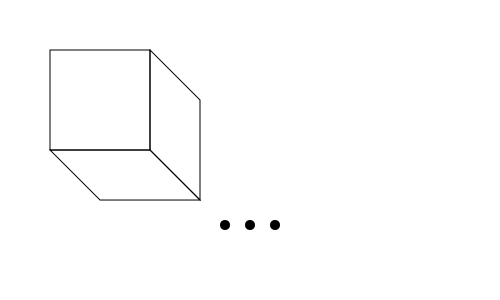In this fractal geometry pattern, what shape will appear in the next iteration, and where will it be positioned relative to the current structure? To determine the next iteration in this fractal pattern, we need to analyze the current structure and identify the rule for progression:

1. The base shape is a square.
2. In each iteration, three new squares are added:
   a. One to the right, tilted 45 degrees clockwise
   b. One below, tilted 45 degrees counterclockwise
   c. One to the bottom-right, maintaining the original orientation

3. The new squares are smaller, with side lengths approximately $\frac{1}{\sqrt{2}}$ times the previous square's side length.

4. This process creates a self-similar pattern that expands outward and downward.

5. For the next iteration, we would expect three new squares to be added to each of the current outermost squares, following the same rule.

6. The most prominent new addition would be a square positioned below and to the right of the current structure, maintaining the original orientation.

7. This new square would have side lengths approximately $(\frac{1}{\sqrt{2}})^2 = \frac{1}{2}$ times the side length of the largest square in the current structure.

Therefore, the next iteration will feature a new square, approximately half the size of the original square, positioned below and to the right of the current structure.
Answer: A square, half the size of the original, below and to the right of the current structure. 